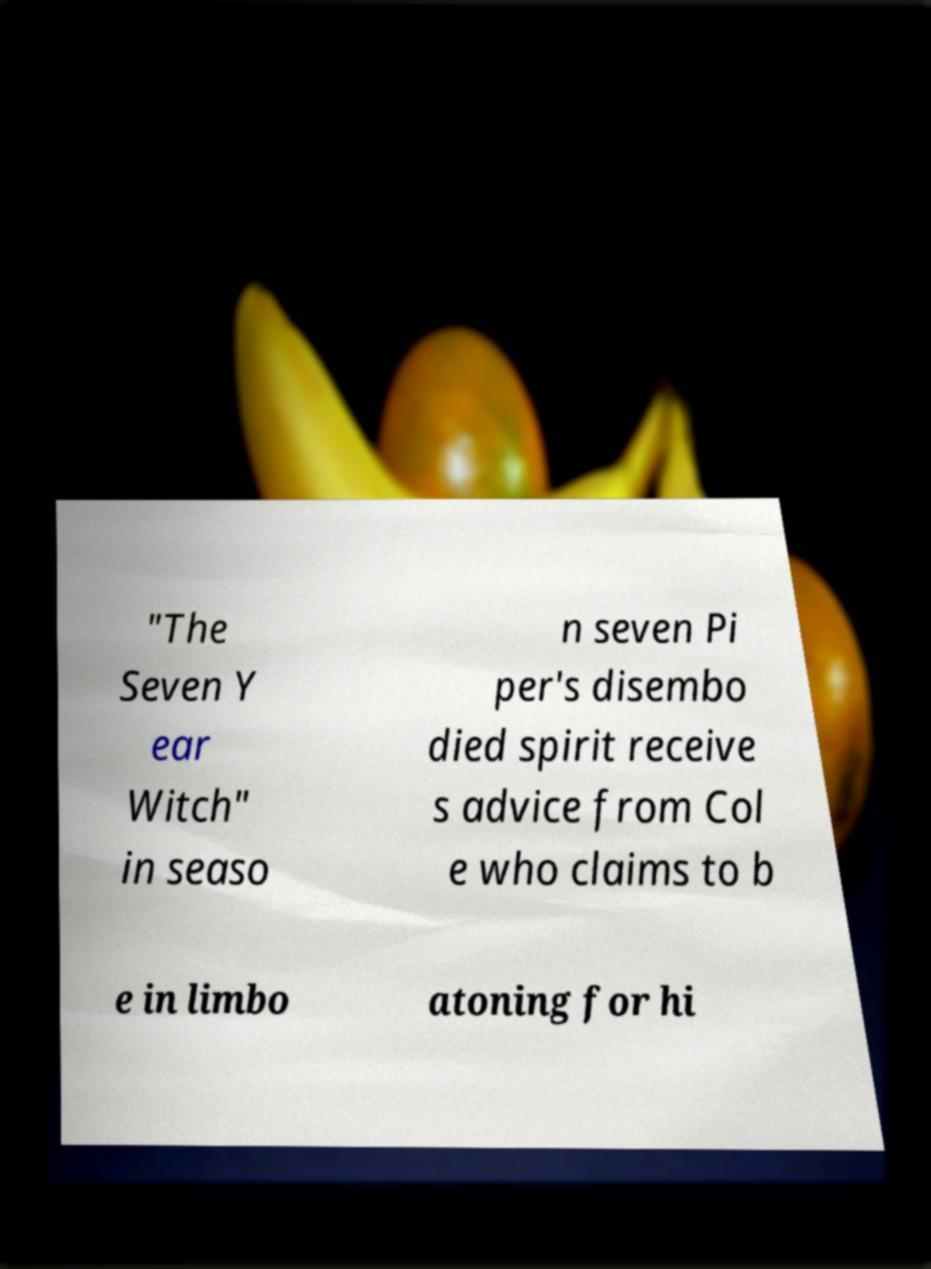Please identify and transcribe the text found in this image. "The Seven Y ear Witch" in seaso n seven Pi per's disembo died spirit receive s advice from Col e who claims to b e in limbo atoning for hi 